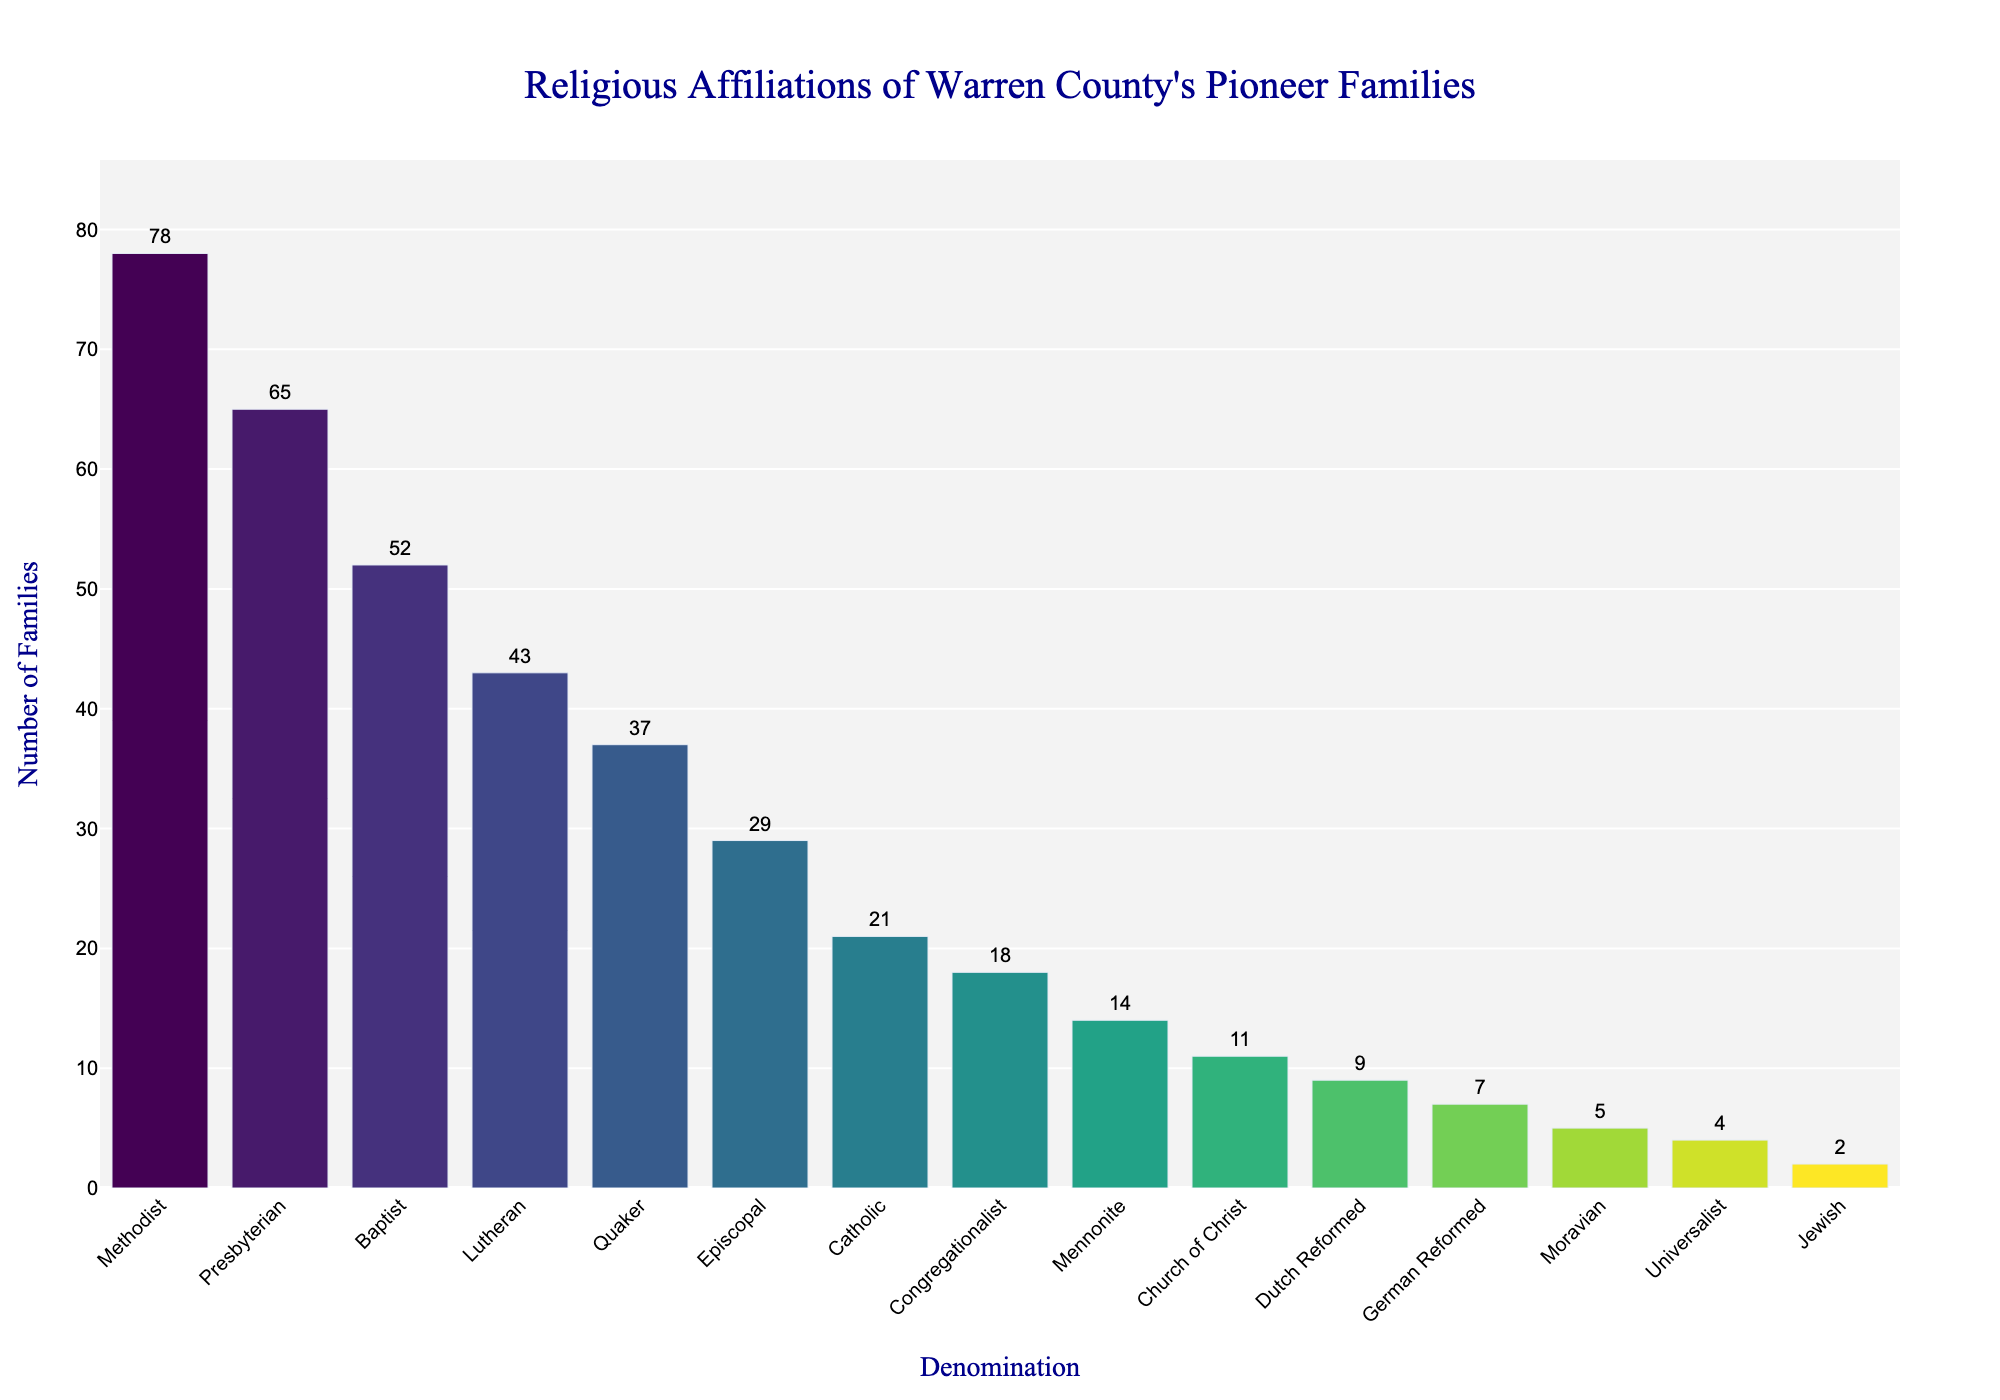What religious affiliation has the highest number of families? The religious affiliation with the highest number of families is the one with the tallest bar in the chart. By looking at the chart, the Methodist denomination has the tallest bar.
Answer: Methodist Which religious affiliation has the lowest number of families? The religious affiliation with the lowest number of families is represented by the shortest bar in the chart. The Jewish denomination has the shortest bar.
Answer: Jewish How many more Methodist families are there compared to Jewish families? To find the difference, we subtract the number of Jewish families from the number of Methodist families. The Methodist denomination has 78 families and the Jewish denomination has 2 families. So, 78 - 2 = 76.
Answer: 76 What is the total number of families in the top three denominations? First, identify the top three denominations by looking at the tallest bars: Methodist (78), Presbyterian (65), and Baptist (52). Then, sum their values: 78 + 65 + 52 = 195.
Answer: 195 What is the combined number of families in the Methodist and Lutheran denominations? Sum the number of families in both denominations. Methodist has 78 families and Lutheran has 43 families. So, 78 + 43 = 121.
Answer: 121 Which denomination has exactly four more families than Mennonite? Find the denomination with a family count of Mennonite (14) plus four. So, 14 + 4 = 18. The Congregationalist denomination has 18 families.
Answer: Congregationalist How does the number of Quaker families compare to the number of Catholic families? The chart indicates that the Quaker denomination has 37 families and the Catholic denomination has 21 families. Compare their values: 37 is greater than 21.
Answer: Quaker has more families Identify the religious affiliation with the fourth highest number of families. By examining the bar heights, the fourth highest bar corresponds to the fourth highest number which is Lutheran with 43 families.
Answer: Lutheran What is the difference in family count between Episcopal and Church of Christ denominations? The Episcopal denomination has 29 families and Church of Christ has 11 families. Subtracting these, 29 - 11 = 18.
Answer: 18 Calculate the average number of families for the denominations that have more than 50 families. Denominations with more than 50 families: Methodist (78), Presbyterian (65), Baptist (52). Calculate the average: (78 + 65 + 52) / 3 = 195 / 3 = 65.
Answer: 65 